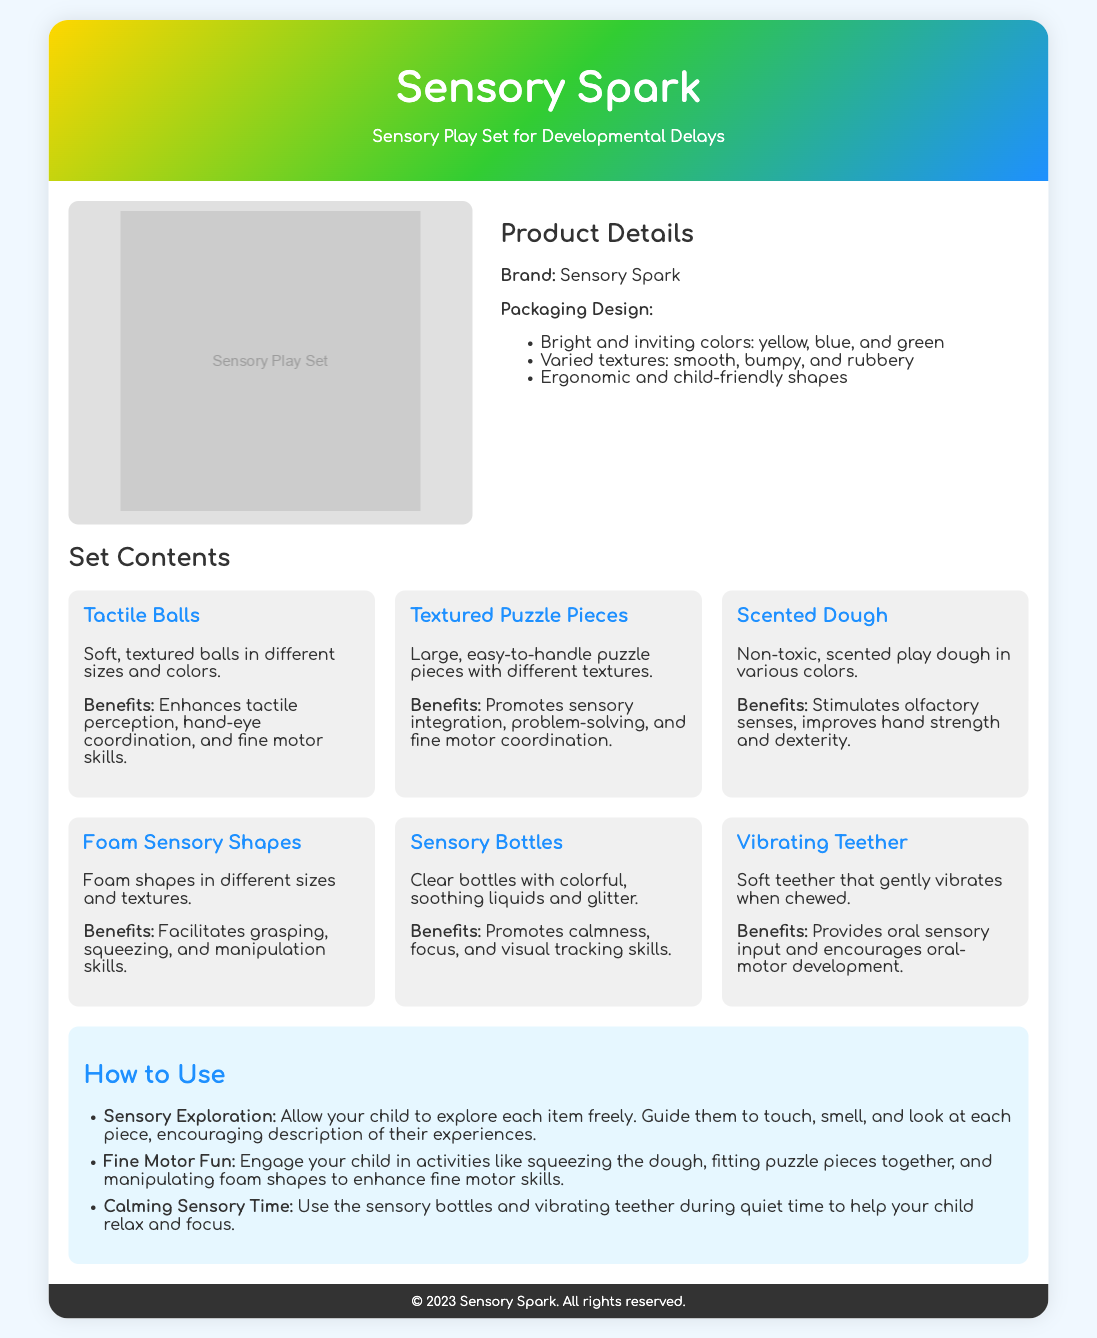what is the brand name? The brand name is stated at the beginning of the product details section in the document.
Answer: Sensory Spark how many components are in the set? The set contents section lists six different components.
Answer: 6 what color is included in the packaging design? The packaging design describes the colors used, which are listed in a bullet point format.
Answer: yellow, blue, green what is one benefit of textured puzzle pieces? The benefits of each component are mentioned below their descriptions, specifically for textured puzzle pieces.
Answer: promotes sensory integration what item stimulates olfactory senses? The item description provides the name of the component that stimulates the olfactory senses.
Answer: Scented Dough how should sensory bottles be used? The usage section provides specific instructions on how to use sensory bottles, allowing for calmness and focus.
Answer: during quiet time what component aids oral-motor development? The benefits section identifies the item that provides oral sensory input and supports oral-motor development.
Answer: Vibrating Teether what is the main purpose of the Sensory Spark set? The title and description highlight the intended use of the product for children with specific needs.
Answer: for Developmental Delays 